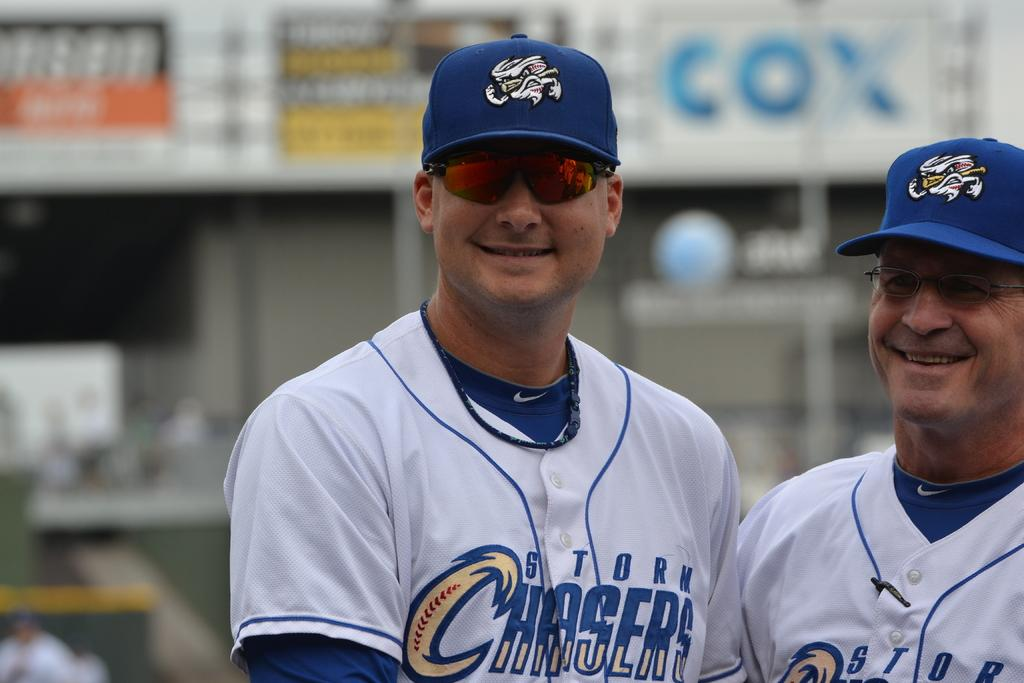<image>
Render a clear and concise summary of the photo. Two men in Storm Chasers uniforms stand together smiling. 